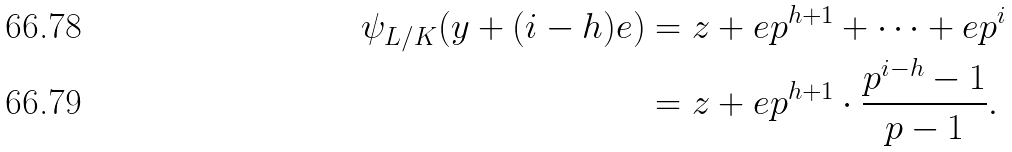<formula> <loc_0><loc_0><loc_500><loc_500>\psi _ { L / K } ( y + ( i - h ) e ) & = z + e p ^ { h + 1 } + \dots + e p ^ { i } \\ & = z + e p ^ { h + 1 } \cdot \frac { p ^ { i - h } - 1 } { p - 1 } .</formula> 